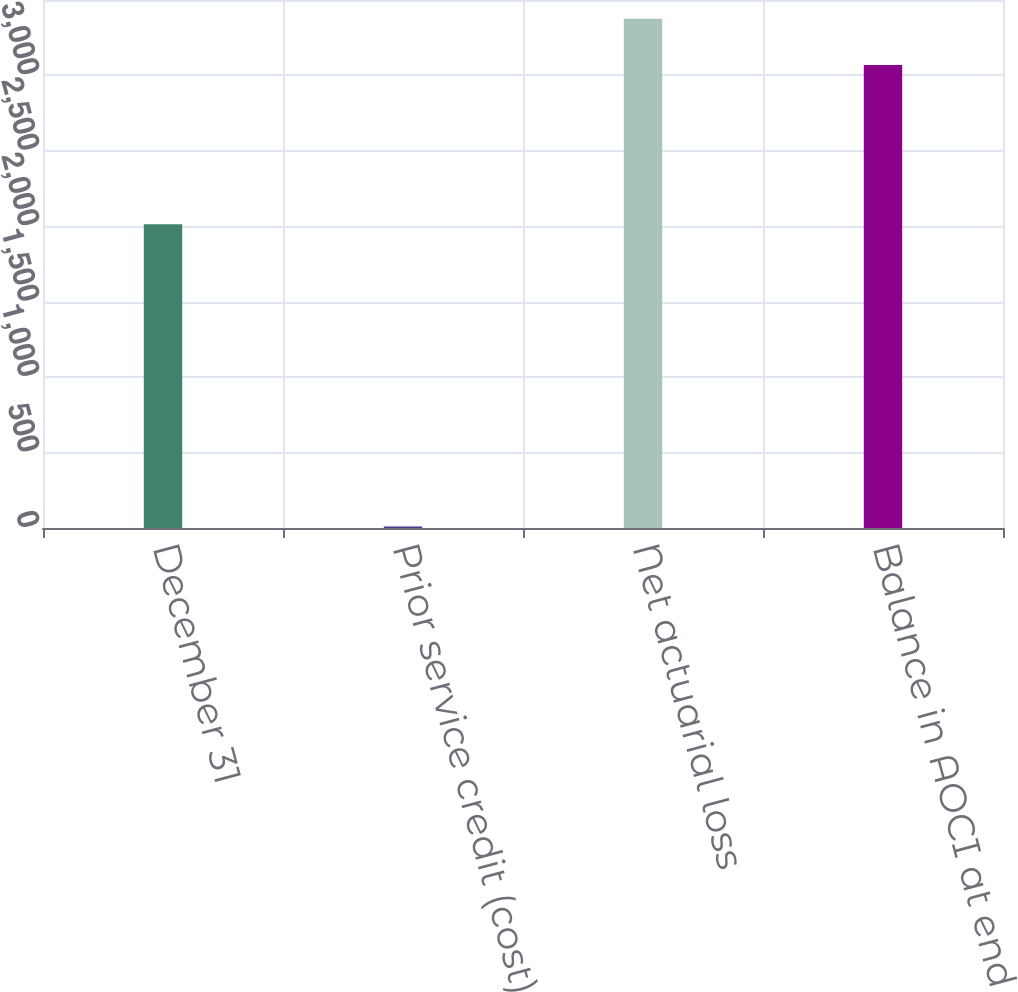Convert chart. <chart><loc_0><loc_0><loc_500><loc_500><bar_chart><fcel>December 31<fcel>Prior service credit (cost)<fcel>Net actuarial loss<fcel>Balance in AOCI at end of year<nl><fcel>2014<fcel>10<fcel>3375.9<fcel>3069<nl></chart> 